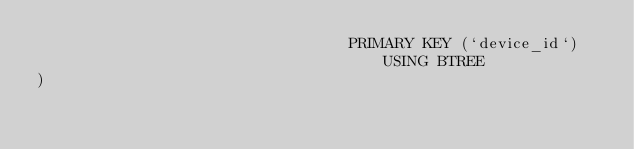<code> <loc_0><loc_0><loc_500><loc_500><_SQL_>                                  PRIMARY KEY (`device_id`) USING BTREE
)</code> 